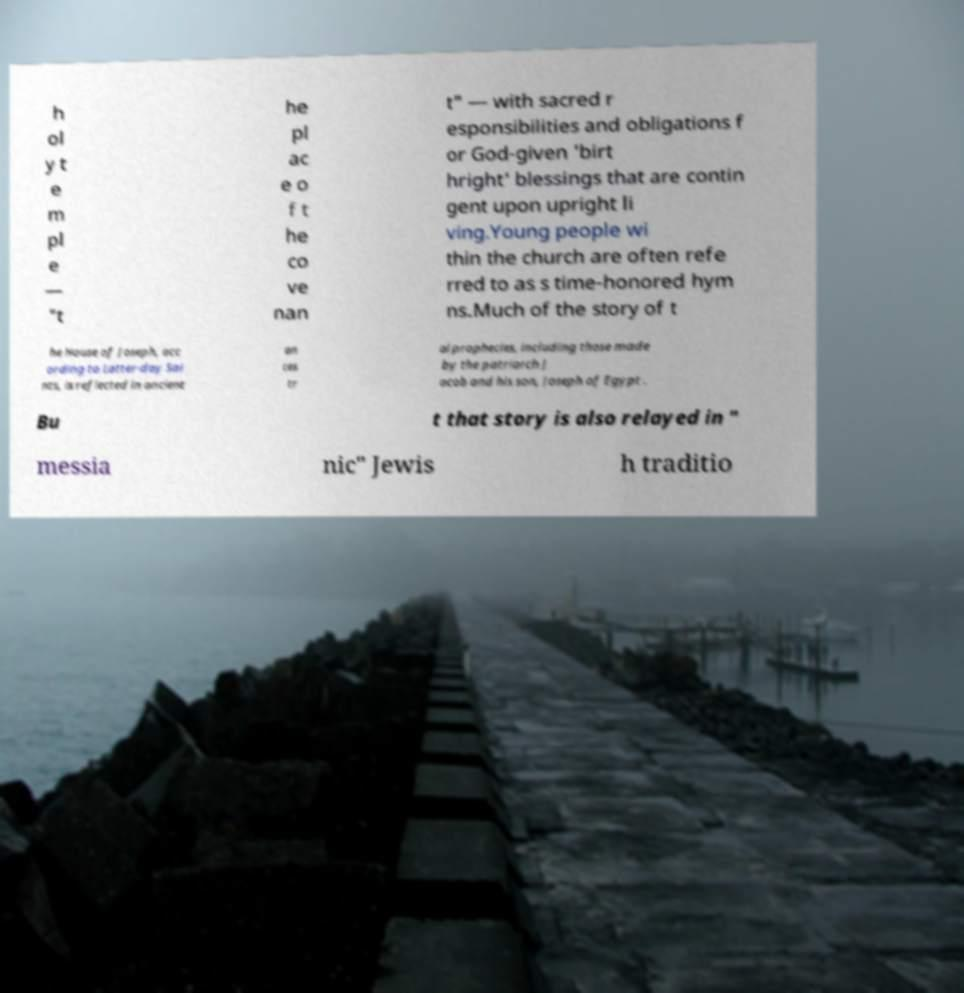I need the written content from this picture converted into text. Can you do that? h ol y t e m pl e — "t he pl ac e o f t he co ve nan t" — with sacred r esponsibilities and obligations f or God-given 'birt hright' blessings that are contin gent upon upright li ving.Young people wi thin the church are often refe rred to as s time-honored hym ns.Much of the story of t he House of Joseph, acc ording to Latter-day Sai nts, is reflected in ancient an ces tr al prophecies, including those made by the patriarch J acob and his son, Joseph of Egypt . Bu t that story is also relayed in " messia nic" Jewis h traditio 